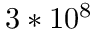<formula> <loc_0><loc_0><loc_500><loc_500>3 * 1 0 ^ { 8 }</formula> 